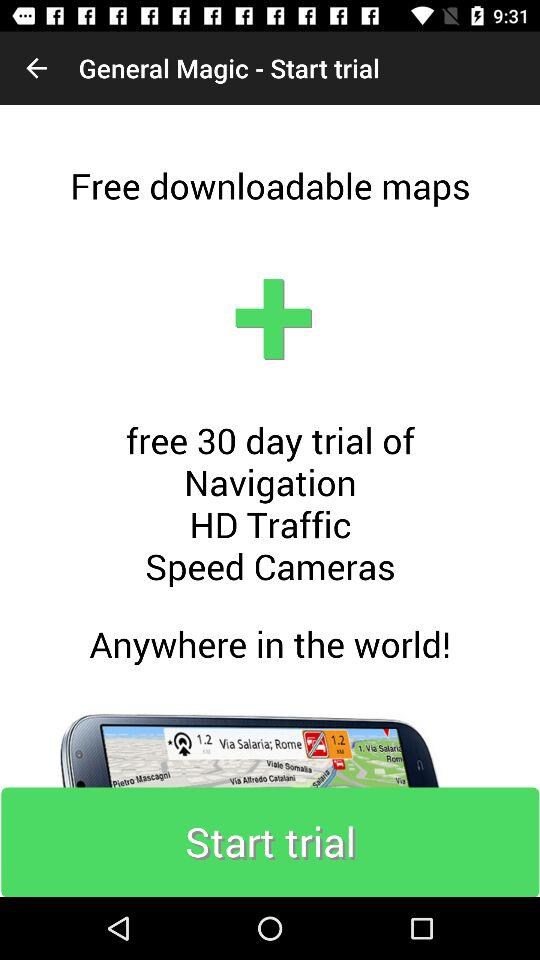Free trial is for how many days? The free trial is for 30 days. 